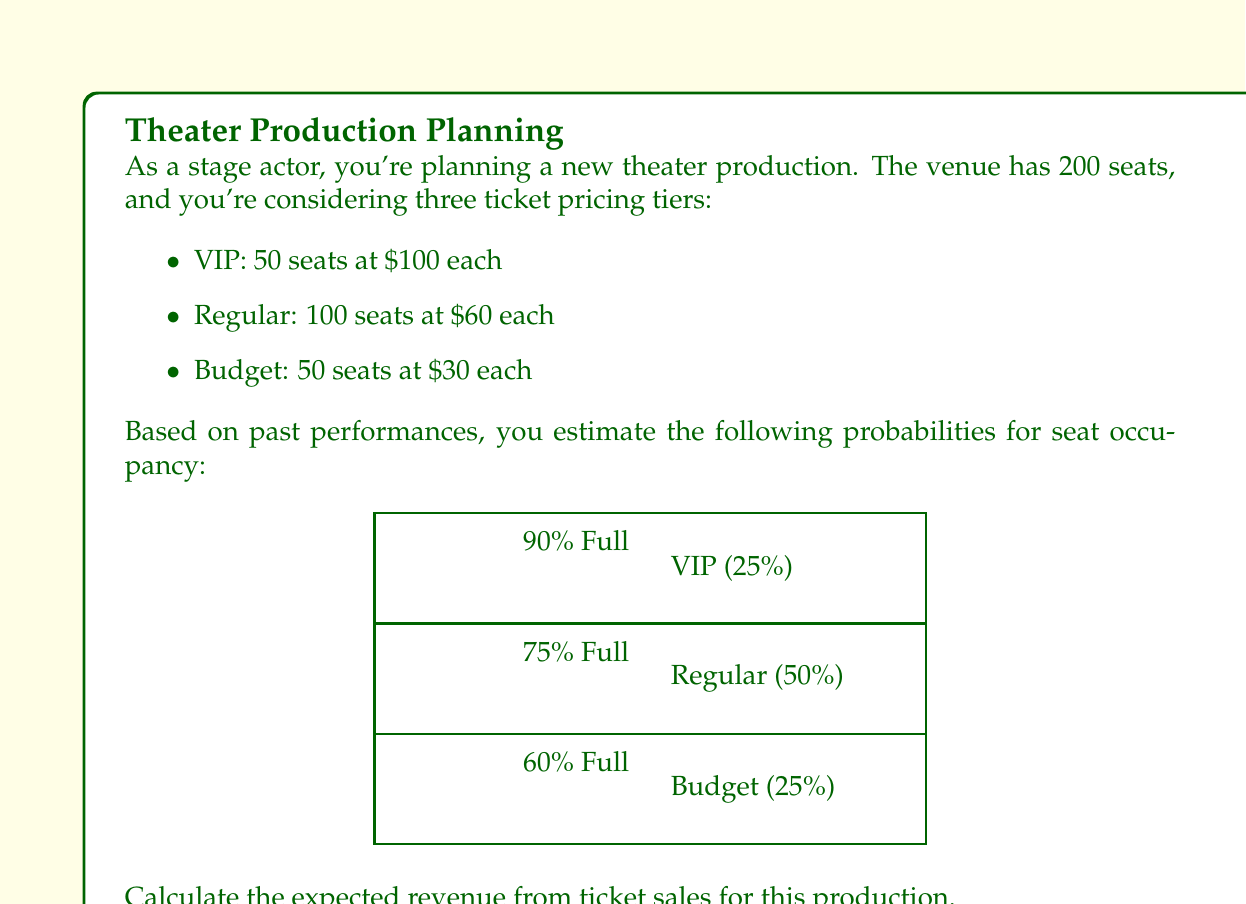Help me with this question. Let's break this down step-by-step:

1) First, we need to calculate the expected number of seats sold for each tier:

   VIP: $50 \times 0.90 = 45$ seats
   Regular: $100 \times 0.75 = 75$ seats
   Budget: $50 \times 0.60 = 30$ seats

2) Now, let's calculate the revenue for each tier:

   VIP: $45 \times \$100 = \$4,500$
   Regular: $75 \times \$60 = \$4,500$
   Budget: $30 \times \$30 = \$900$

3) The expected total revenue is the sum of these:

   $$\text{Expected Revenue} = \$4,500 + \$4,500 + \$900 = \$9,900$$

Therefore, the expected revenue from ticket sales for this production is $\$9,900$.
Answer: $\$9,900$ 